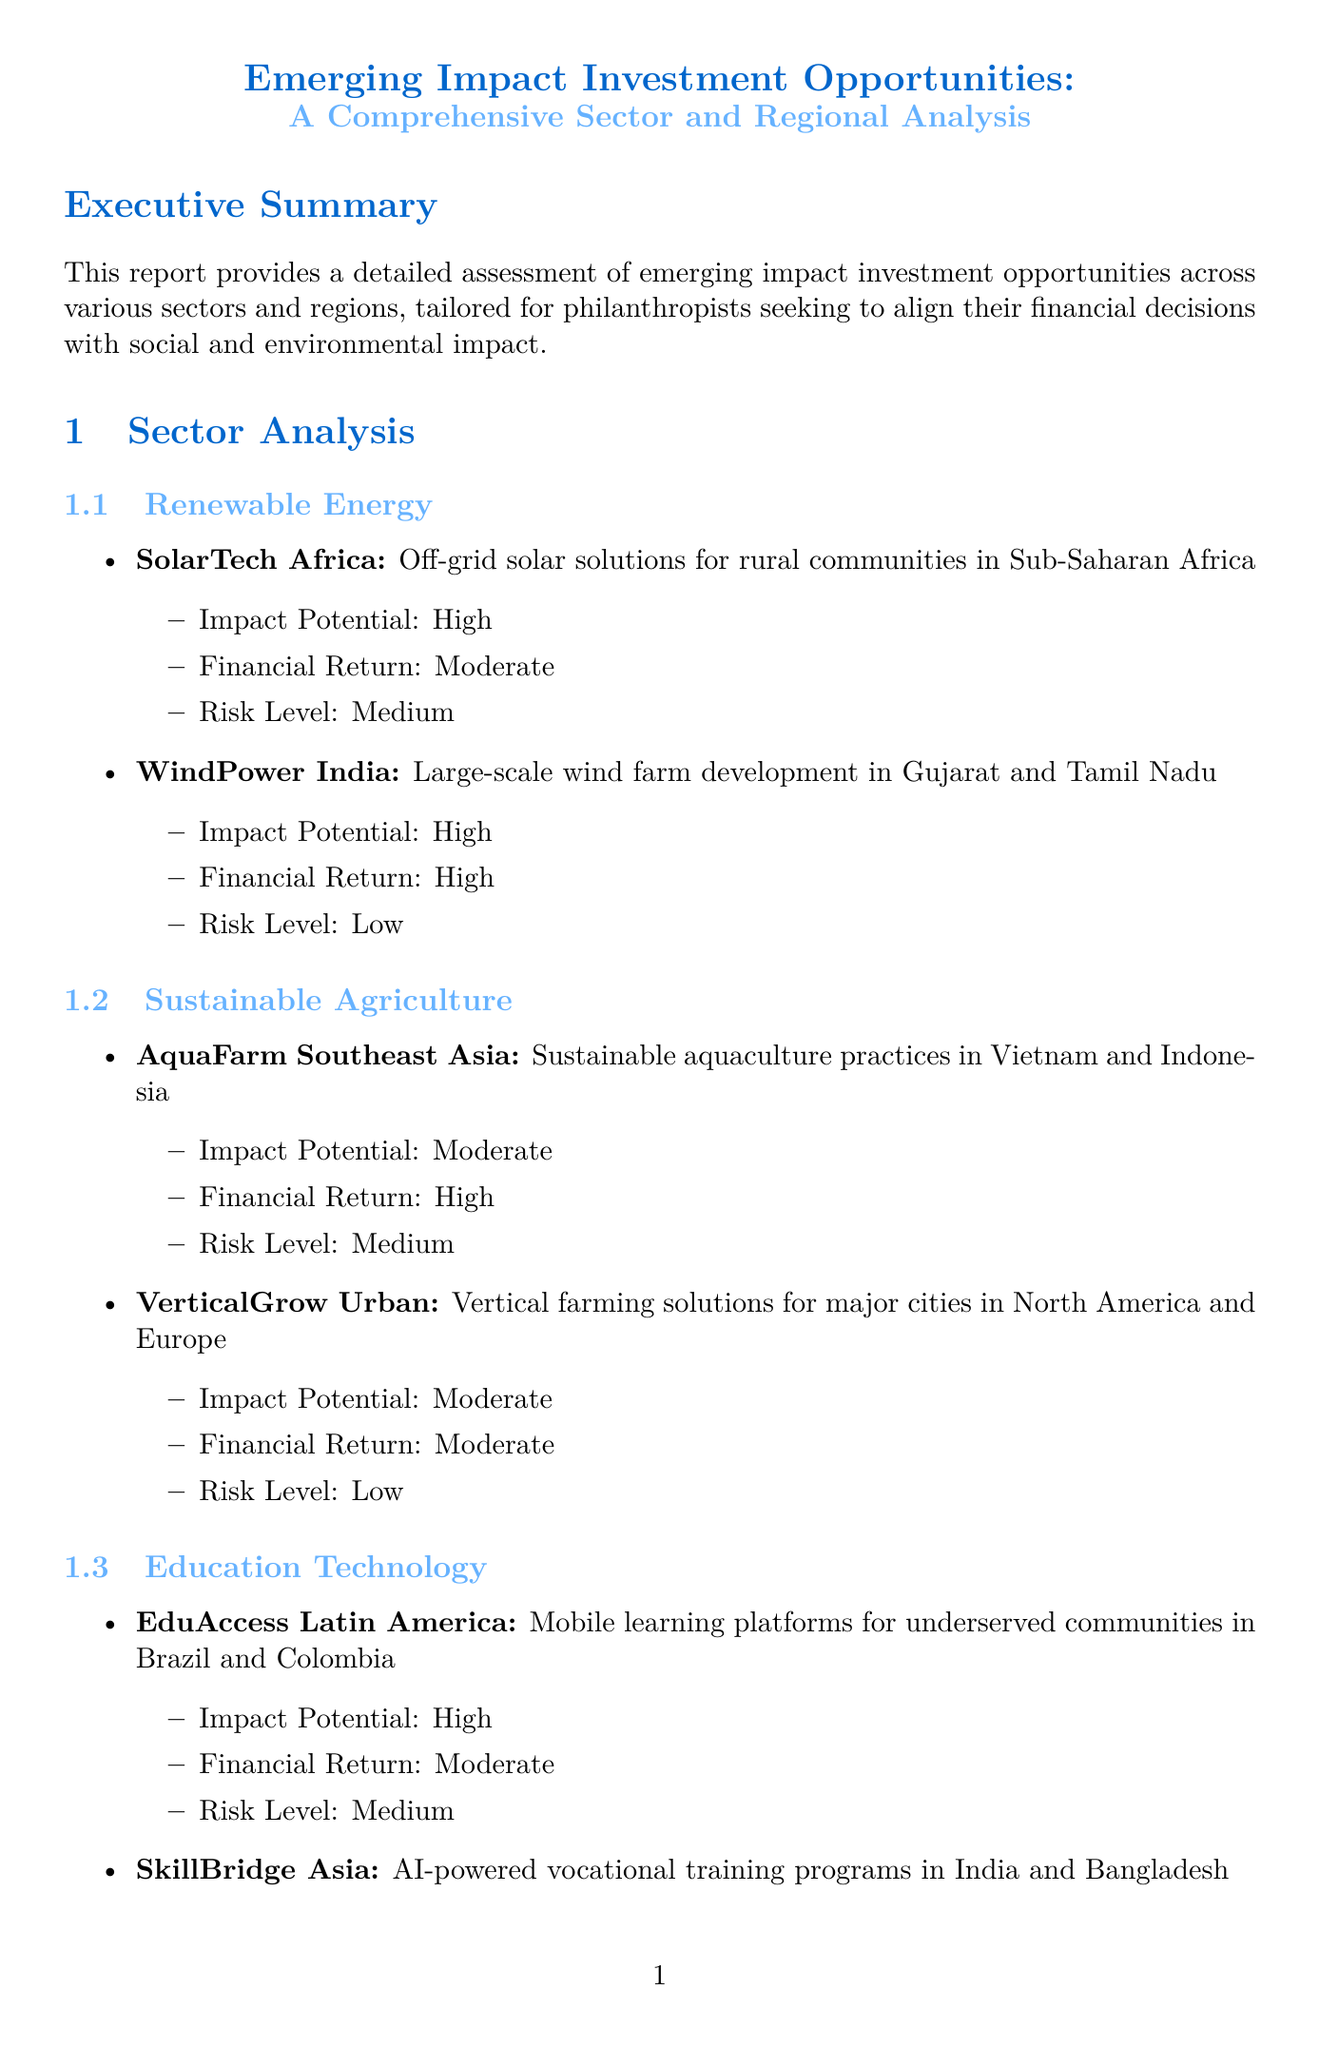What is the title of the report? The title of the report is stated at the beginning of the document.
Answer: Emerging Impact Investment Opportunities: A Comprehensive Sector and Regional Analysis How many investment strategies are outlined in the report? The investment strategies section lists three different strategies.
Answer: 3 What is the impact potential of WindPower India? The document provides specific impact potentials for each opportunity listed.
Answer: High What are the key opportunities in Southeast Asia? Key opportunities are summarized in the regional analysis section.
Answer: Sustainable agriculture and aquaculture, Clean water and sanitation projects, E-commerce for rural communities What is the risk level associated with SkillBridge Asia? The risk level is specified for each opportunity under the education technology sector.
Answer: Low Which sector has opportunities in vertical farming solutions? The sector section provides names of each sector along with their opportunities.
Answer: Sustainable Agriculture What challenges are faced in Latin America? The document outlines specific challenges for each region.
Answer: Economic volatility in some countries, Complex regulatory environments, Social and income inequality What is the suitability of the Blended Finance Approach? The suitability for each investment strategy is detailed within the investment strategies section.
Answer: High for philanthropists looking to catalyze larger capital flows What does the conclusion recommend for philanthropists? Recommendations are explicitly mentioned in the conclusion of the report.
Answer: Develop a clear impact thesis aligned with philanthropic goals 